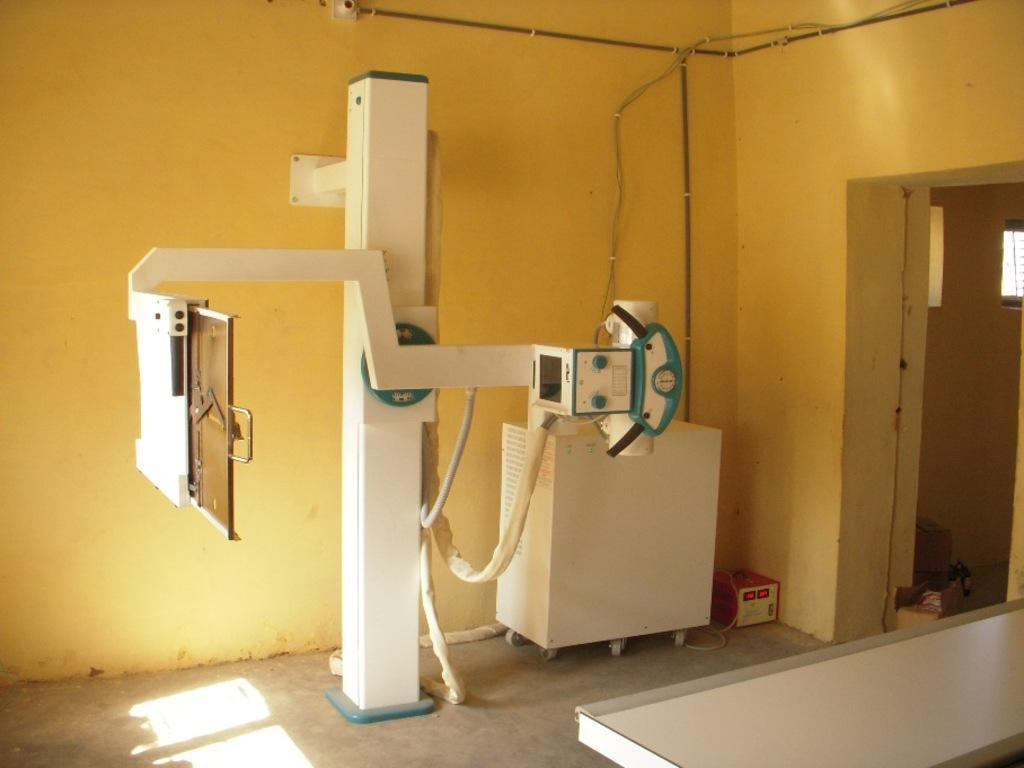What objects are on the ground in the image? There are machines on the ground in the image. What can be seen on the right side of the image? There is a door and a table on the right side of the image. What is written or drawn on the wall in the image? There are writings on the wall in the image. What type of stew is being served on the table in the image? There is no stew present in the image; it features machines on the ground, a door, a table, and writings on the wall. What color is the collar of the dog in the image? There is no dog, let alone a collar, present in the image. 